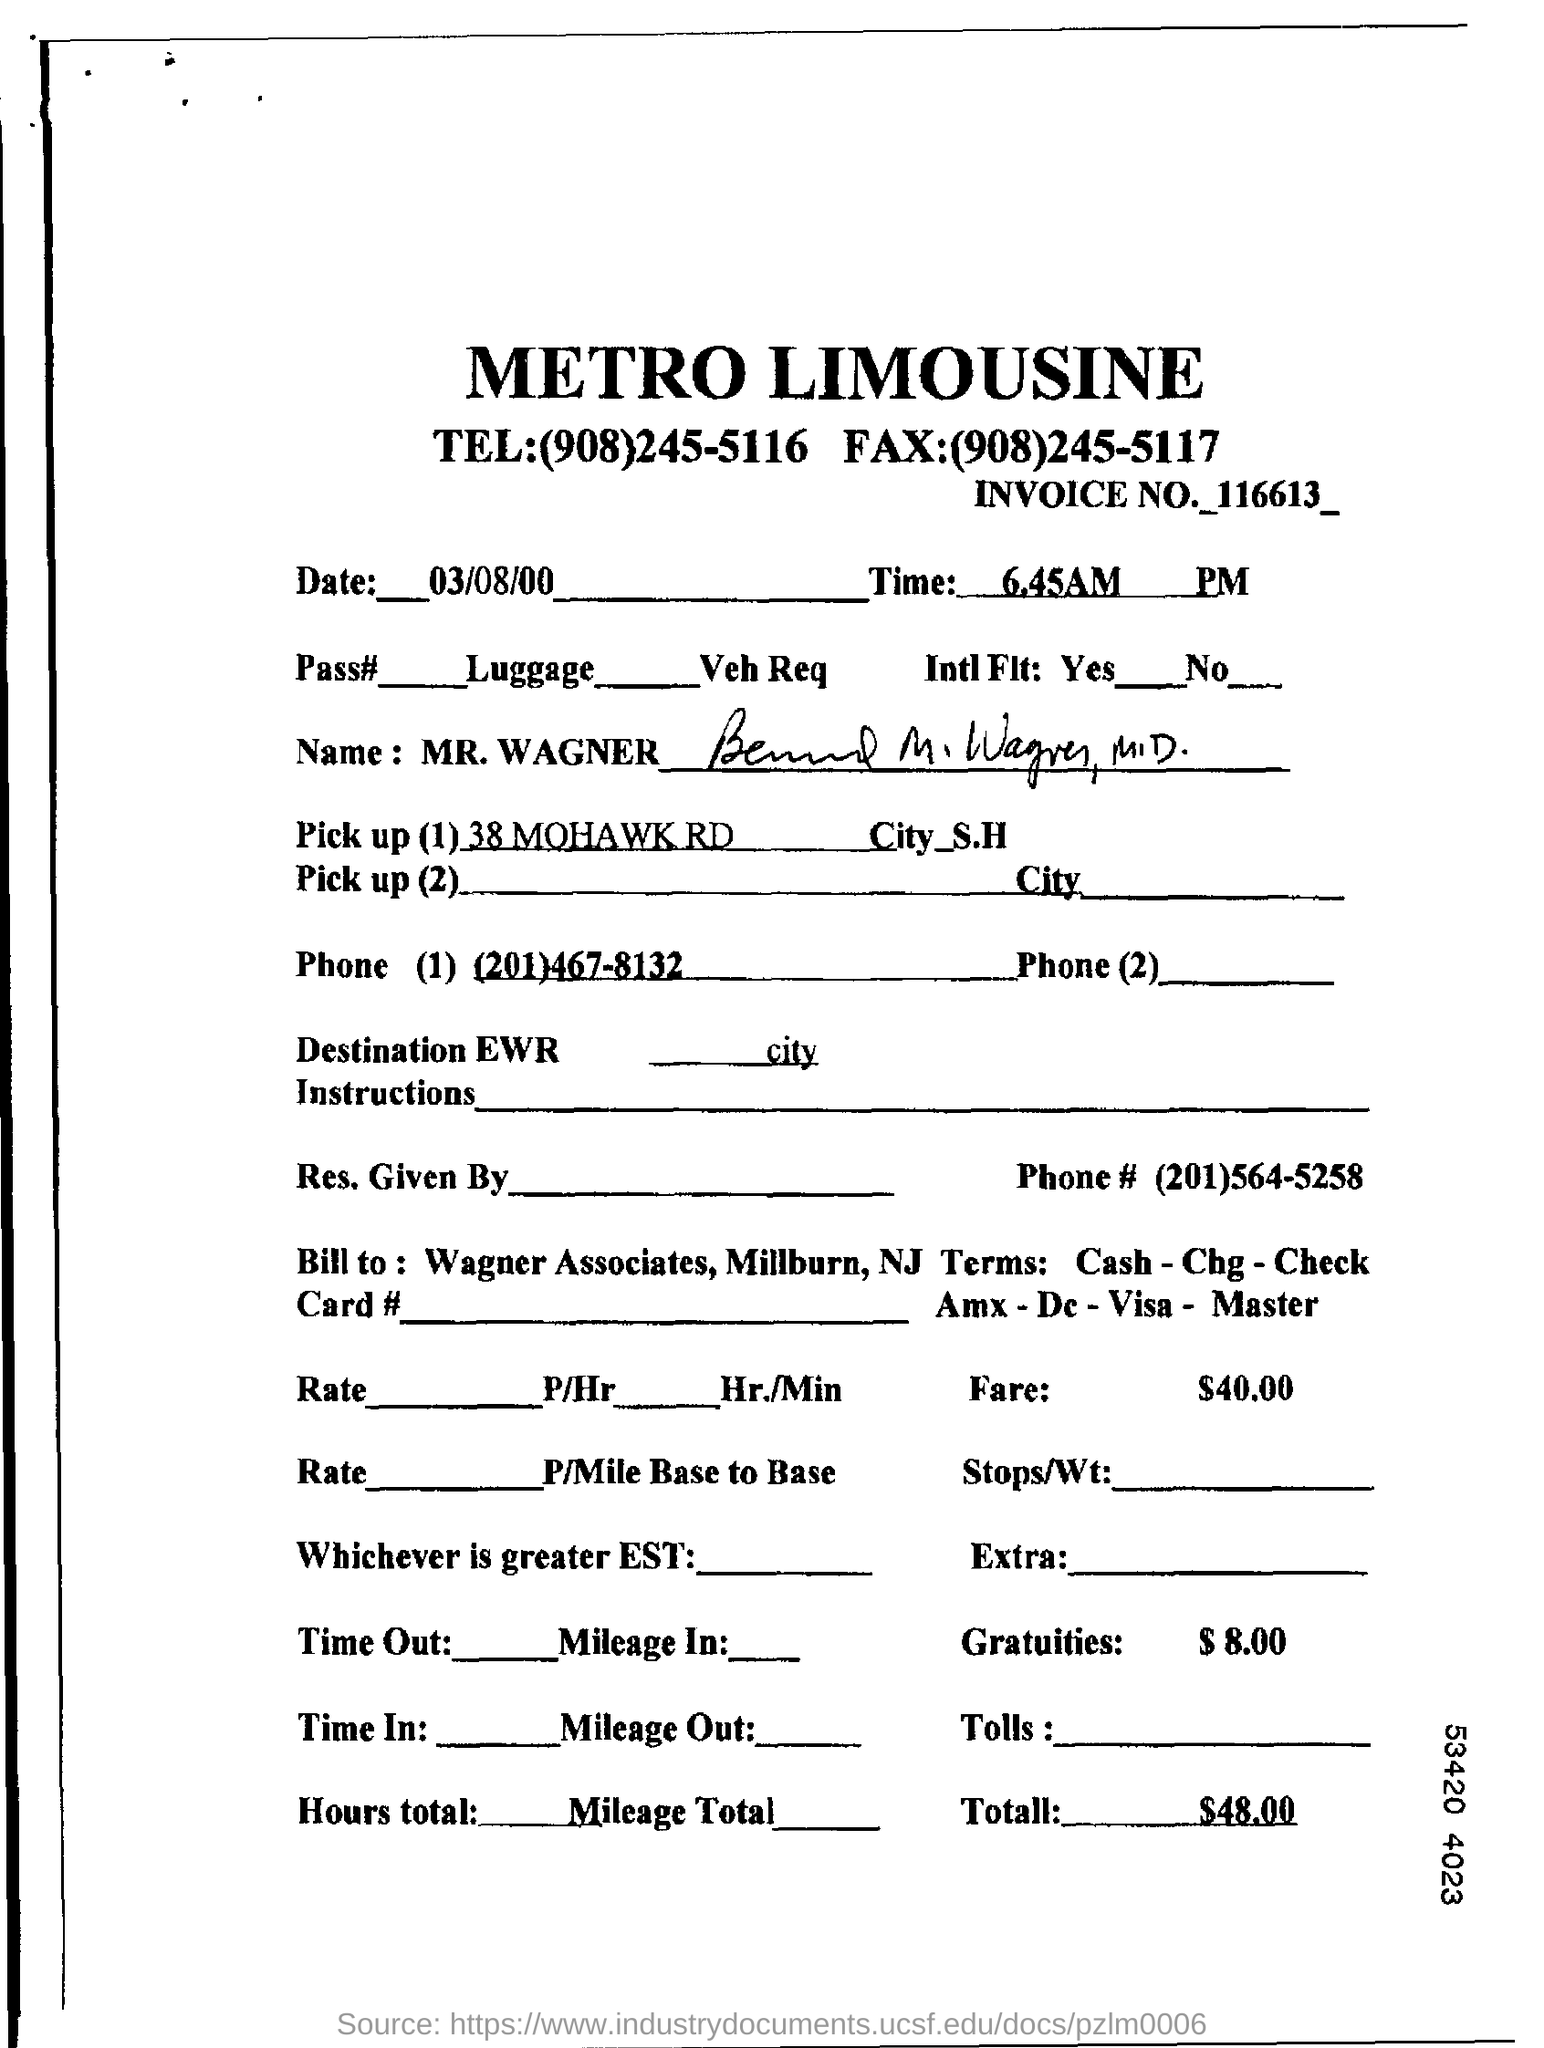Identify some key points in this picture. The time mentioned in this document is 6.45 AM. The invoice number provided in this document is 116613... The date mentioned in this document is March 8, 2000. The total cost per the document is $48.00. 